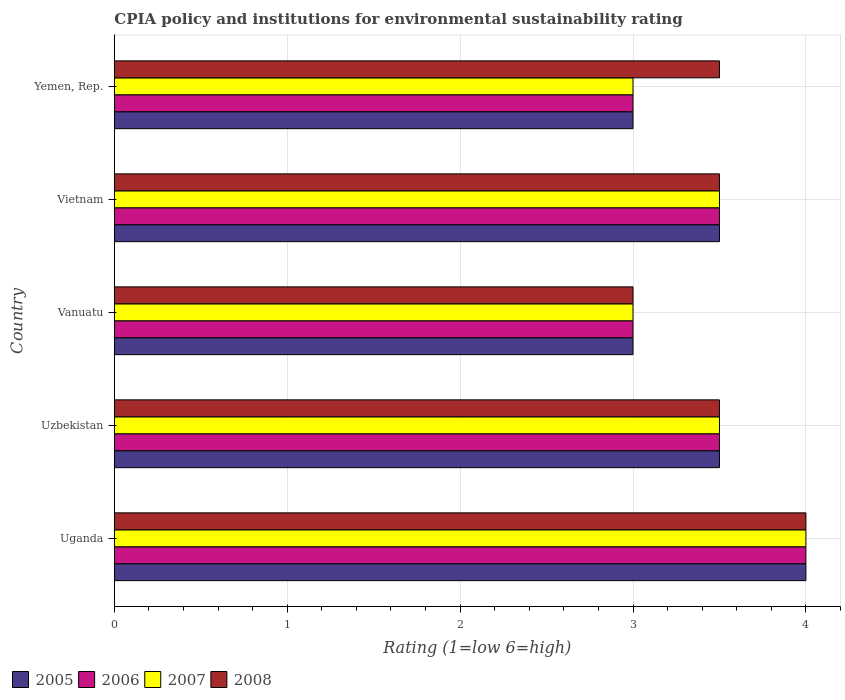How many bars are there on the 2nd tick from the bottom?
Your answer should be very brief. 4. What is the label of the 1st group of bars from the top?
Your response must be concise. Yemen, Rep. Across all countries, what is the maximum CPIA rating in 2007?
Provide a short and direct response. 4. In which country was the CPIA rating in 2007 maximum?
Your answer should be very brief. Uganda. In which country was the CPIA rating in 2007 minimum?
Provide a short and direct response. Vanuatu. What is the total CPIA rating in 2007 in the graph?
Provide a succinct answer. 17. What is the difference between the CPIA rating in 2005 in Uganda and that in Vanuatu?
Your response must be concise. 1. What is the difference between the CPIA rating in 2006 in Uzbekistan and the CPIA rating in 2007 in Yemen, Rep.?
Keep it short and to the point. 0.5. What is the difference between the CPIA rating in 2005 and CPIA rating in 2008 in Uganda?
Make the answer very short. 0. What is the ratio of the CPIA rating in 2005 in Uzbekistan to that in Yemen, Rep.?
Your response must be concise. 1.17. What is the difference between the highest and the second highest CPIA rating in 2005?
Provide a short and direct response. 0.5. Is the sum of the CPIA rating in 2007 in Uzbekistan and Vietnam greater than the maximum CPIA rating in 2005 across all countries?
Offer a very short reply. Yes. What does the 2nd bar from the top in Yemen, Rep. represents?
Your answer should be very brief. 2007. What does the 4th bar from the bottom in Uganda represents?
Ensure brevity in your answer.  2008. Is it the case that in every country, the sum of the CPIA rating in 2005 and CPIA rating in 2007 is greater than the CPIA rating in 2008?
Provide a succinct answer. Yes. How many bars are there?
Your answer should be very brief. 20. Are all the bars in the graph horizontal?
Make the answer very short. Yes. What is the difference between two consecutive major ticks on the X-axis?
Your response must be concise. 1. Where does the legend appear in the graph?
Your response must be concise. Bottom left. How are the legend labels stacked?
Your answer should be compact. Horizontal. What is the title of the graph?
Provide a short and direct response. CPIA policy and institutions for environmental sustainability rating. What is the label or title of the X-axis?
Offer a very short reply. Rating (1=low 6=high). What is the label or title of the Y-axis?
Offer a very short reply. Country. What is the Rating (1=low 6=high) of 2006 in Uganda?
Ensure brevity in your answer.  4. What is the Rating (1=low 6=high) in 2007 in Uganda?
Ensure brevity in your answer.  4. What is the Rating (1=low 6=high) of 2006 in Uzbekistan?
Make the answer very short. 3.5. What is the Rating (1=low 6=high) of 2008 in Uzbekistan?
Your answer should be compact. 3.5. What is the Rating (1=low 6=high) of 2006 in Vanuatu?
Provide a short and direct response. 3. What is the Rating (1=low 6=high) of 2007 in Vanuatu?
Keep it short and to the point. 3. What is the Rating (1=low 6=high) in 2008 in Vanuatu?
Provide a short and direct response. 3. What is the Rating (1=low 6=high) of 2005 in Vietnam?
Give a very brief answer. 3.5. What is the Rating (1=low 6=high) of 2006 in Vietnam?
Your answer should be compact. 3.5. What is the Rating (1=low 6=high) in 2007 in Vietnam?
Offer a terse response. 3.5. What is the Rating (1=low 6=high) in 2005 in Yemen, Rep.?
Ensure brevity in your answer.  3. What is the Rating (1=low 6=high) in 2007 in Yemen, Rep.?
Keep it short and to the point. 3. Across all countries, what is the maximum Rating (1=low 6=high) in 2005?
Your answer should be very brief. 4. Across all countries, what is the minimum Rating (1=low 6=high) of 2005?
Keep it short and to the point. 3. Across all countries, what is the minimum Rating (1=low 6=high) of 2007?
Your answer should be very brief. 3. What is the total Rating (1=low 6=high) of 2005 in the graph?
Give a very brief answer. 17. What is the total Rating (1=low 6=high) of 2006 in the graph?
Provide a short and direct response. 17. What is the total Rating (1=low 6=high) of 2008 in the graph?
Provide a succinct answer. 17.5. What is the difference between the Rating (1=low 6=high) in 2005 in Uganda and that in Vanuatu?
Provide a short and direct response. 1. What is the difference between the Rating (1=low 6=high) in 2007 in Uganda and that in Vietnam?
Your answer should be compact. 0.5. What is the difference between the Rating (1=low 6=high) of 2008 in Uganda and that in Vietnam?
Ensure brevity in your answer.  0.5. What is the difference between the Rating (1=low 6=high) in 2007 in Uganda and that in Yemen, Rep.?
Provide a short and direct response. 1. What is the difference between the Rating (1=low 6=high) in 2008 in Uganda and that in Yemen, Rep.?
Provide a succinct answer. 0.5. What is the difference between the Rating (1=low 6=high) of 2006 in Uzbekistan and that in Vanuatu?
Make the answer very short. 0.5. What is the difference between the Rating (1=low 6=high) in 2005 in Uzbekistan and that in Vietnam?
Offer a terse response. 0. What is the difference between the Rating (1=low 6=high) in 2006 in Uzbekistan and that in Vietnam?
Provide a short and direct response. 0. What is the difference between the Rating (1=low 6=high) in 2007 in Uzbekistan and that in Vietnam?
Your answer should be compact. 0. What is the difference between the Rating (1=low 6=high) in 2005 in Uzbekistan and that in Yemen, Rep.?
Your answer should be compact. 0.5. What is the difference between the Rating (1=low 6=high) of 2006 in Uzbekistan and that in Yemen, Rep.?
Give a very brief answer. 0.5. What is the difference between the Rating (1=low 6=high) in 2007 in Uzbekistan and that in Yemen, Rep.?
Make the answer very short. 0.5. What is the difference between the Rating (1=low 6=high) of 2006 in Vanuatu and that in Vietnam?
Your answer should be very brief. -0.5. What is the difference between the Rating (1=low 6=high) of 2007 in Vanuatu and that in Vietnam?
Your answer should be very brief. -0.5. What is the difference between the Rating (1=low 6=high) of 2005 in Vanuatu and that in Yemen, Rep.?
Provide a succinct answer. 0. What is the difference between the Rating (1=low 6=high) in 2006 in Vanuatu and that in Yemen, Rep.?
Your answer should be compact. 0. What is the difference between the Rating (1=low 6=high) of 2007 in Vanuatu and that in Yemen, Rep.?
Your answer should be very brief. 0. What is the difference between the Rating (1=low 6=high) of 2008 in Vanuatu and that in Yemen, Rep.?
Ensure brevity in your answer.  -0.5. What is the difference between the Rating (1=low 6=high) of 2005 in Vietnam and that in Yemen, Rep.?
Offer a terse response. 0.5. What is the difference between the Rating (1=low 6=high) of 2006 in Vietnam and that in Yemen, Rep.?
Keep it short and to the point. 0.5. What is the difference between the Rating (1=low 6=high) in 2008 in Vietnam and that in Yemen, Rep.?
Your answer should be compact. 0. What is the difference between the Rating (1=low 6=high) of 2005 in Uganda and the Rating (1=low 6=high) of 2006 in Uzbekistan?
Offer a terse response. 0.5. What is the difference between the Rating (1=low 6=high) in 2005 in Uganda and the Rating (1=low 6=high) in 2007 in Uzbekistan?
Make the answer very short. 0.5. What is the difference between the Rating (1=low 6=high) in 2007 in Uganda and the Rating (1=low 6=high) in 2008 in Uzbekistan?
Give a very brief answer. 0.5. What is the difference between the Rating (1=low 6=high) of 2005 in Uganda and the Rating (1=low 6=high) of 2007 in Vanuatu?
Provide a short and direct response. 1. What is the difference between the Rating (1=low 6=high) of 2006 in Uganda and the Rating (1=low 6=high) of 2008 in Vanuatu?
Make the answer very short. 1. What is the difference between the Rating (1=low 6=high) of 2007 in Uganda and the Rating (1=low 6=high) of 2008 in Vanuatu?
Offer a very short reply. 1. What is the difference between the Rating (1=low 6=high) in 2005 in Uganda and the Rating (1=low 6=high) in 2008 in Vietnam?
Provide a short and direct response. 0.5. What is the difference between the Rating (1=low 6=high) in 2006 in Uganda and the Rating (1=low 6=high) in 2007 in Vietnam?
Provide a short and direct response. 0.5. What is the difference between the Rating (1=low 6=high) of 2007 in Uganda and the Rating (1=low 6=high) of 2008 in Vietnam?
Ensure brevity in your answer.  0.5. What is the difference between the Rating (1=low 6=high) of 2005 in Uganda and the Rating (1=low 6=high) of 2006 in Yemen, Rep.?
Provide a succinct answer. 1. What is the difference between the Rating (1=low 6=high) in 2005 in Uganda and the Rating (1=low 6=high) in 2007 in Yemen, Rep.?
Ensure brevity in your answer.  1. What is the difference between the Rating (1=low 6=high) of 2005 in Uganda and the Rating (1=low 6=high) of 2008 in Yemen, Rep.?
Make the answer very short. 0.5. What is the difference between the Rating (1=low 6=high) of 2006 in Uganda and the Rating (1=low 6=high) of 2008 in Yemen, Rep.?
Offer a terse response. 0.5. What is the difference between the Rating (1=low 6=high) in 2005 in Uzbekistan and the Rating (1=low 6=high) in 2006 in Vanuatu?
Give a very brief answer. 0.5. What is the difference between the Rating (1=low 6=high) in 2005 in Uzbekistan and the Rating (1=low 6=high) in 2007 in Vanuatu?
Your response must be concise. 0.5. What is the difference between the Rating (1=low 6=high) in 2005 in Uzbekistan and the Rating (1=low 6=high) in 2008 in Vanuatu?
Provide a short and direct response. 0.5. What is the difference between the Rating (1=low 6=high) of 2005 in Uzbekistan and the Rating (1=low 6=high) of 2007 in Vietnam?
Provide a short and direct response. 0. What is the difference between the Rating (1=low 6=high) in 2006 in Uzbekistan and the Rating (1=low 6=high) in 2007 in Vietnam?
Provide a succinct answer. 0. What is the difference between the Rating (1=low 6=high) of 2006 in Uzbekistan and the Rating (1=low 6=high) of 2008 in Vietnam?
Offer a terse response. 0. What is the difference between the Rating (1=low 6=high) of 2007 in Uzbekistan and the Rating (1=low 6=high) of 2008 in Vietnam?
Ensure brevity in your answer.  0. What is the difference between the Rating (1=low 6=high) in 2006 in Uzbekistan and the Rating (1=low 6=high) in 2008 in Yemen, Rep.?
Provide a short and direct response. 0. What is the difference between the Rating (1=low 6=high) in 2007 in Uzbekistan and the Rating (1=low 6=high) in 2008 in Yemen, Rep.?
Keep it short and to the point. 0. What is the difference between the Rating (1=low 6=high) in 2005 in Vanuatu and the Rating (1=low 6=high) in 2007 in Vietnam?
Make the answer very short. -0.5. What is the difference between the Rating (1=low 6=high) of 2005 in Vanuatu and the Rating (1=low 6=high) of 2008 in Vietnam?
Provide a short and direct response. -0.5. What is the difference between the Rating (1=low 6=high) in 2006 in Vanuatu and the Rating (1=low 6=high) in 2007 in Vietnam?
Provide a succinct answer. -0.5. What is the difference between the Rating (1=low 6=high) of 2007 in Vanuatu and the Rating (1=low 6=high) of 2008 in Vietnam?
Your answer should be compact. -0.5. What is the difference between the Rating (1=low 6=high) of 2005 in Vanuatu and the Rating (1=low 6=high) of 2007 in Yemen, Rep.?
Ensure brevity in your answer.  0. What is the difference between the Rating (1=low 6=high) of 2005 in Vanuatu and the Rating (1=low 6=high) of 2008 in Yemen, Rep.?
Offer a very short reply. -0.5. What is the difference between the Rating (1=low 6=high) of 2006 in Vanuatu and the Rating (1=low 6=high) of 2007 in Yemen, Rep.?
Give a very brief answer. 0. What is the difference between the Rating (1=low 6=high) of 2006 in Vanuatu and the Rating (1=low 6=high) of 2008 in Yemen, Rep.?
Your answer should be very brief. -0.5. What is the difference between the Rating (1=low 6=high) of 2005 in Vietnam and the Rating (1=low 6=high) of 2006 in Yemen, Rep.?
Provide a short and direct response. 0.5. What is the difference between the Rating (1=low 6=high) in 2005 in Vietnam and the Rating (1=low 6=high) in 2008 in Yemen, Rep.?
Provide a succinct answer. 0. What is the difference between the Rating (1=low 6=high) in 2006 in Vietnam and the Rating (1=low 6=high) in 2007 in Yemen, Rep.?
Keep it short and to the point. 0.5. What is the difference between the Rating (1=low 6=high) of 2006 in Vietnam and the Rating (1=low 6=high) of 2008 in Yemen, Rep.?
Provide a short and direct response. 0. What is the difference between the Rating (1=low 6=high) in 2007 in Vietnam and the Rating (1=low 6=high) in 2008 in Yemen, Rep.?
Offer a very short reply. 0. What is the average Rating (1=low 6=high) of 2007 per country?
Keep it short and to the point. 3.4. What is the average Rating (1=low 6=high) of 2008 per country?
Provide a short and direct response. 3.5. What is the difference between the Rating (1=low 6=high) of 2005 and Rating (1=low 6=high) of 2008 in Uganda?
Your answer should be very brief. 0. What is the difference between the Rating (1=low 6=high) of 2006 and Rating (1=low 6=high) of 2008 in Uganda?
Keep it short and to the point. 0. What is the difference between the Rating (1=low 6=high) in 2005 and Rating (1=low 6=high) in 2006 in Uzbekistan?
Provide a short and direct response. 0. What is the difference between the Rating (1=low 6=high) of 2005 and Rating (1=low 6=high) of 2007 in Uzbekistan?
Provide a short and direct response. 0. What is the difference between the Rating (1=low 6=high) of 2005 and Rating (1=low 6=high) of 2008 in Uzbekistan?
Provide a succinct answer. 0. What is the difference between the Rating (1=low 6=high) of 2007 and Rating (1=low 6=high) of 2008 in Uzbekistan?
Give a very brief answer. 0. What is the difference between the Rating (1=low 6=high) in 2005 and Rating (1=low 6=high) in 2006 in Vanuatu?
Offer a very short reply. 0. What is the difference between the Rating (1=low 6=high) in 2005 and Rating (1=low 6=high) in 2007 in Vanuatu?
Provide a short and direct response. 0. What is the difference between the Rating (1=low 6=high) in 2005 and Rating (1=low 6=high) in 2008 in Vanuatu?
Ensure brevity in your answer.  0. What is the difference between the Rating (1=low 6=high) in 2006 and Rating (1=low 6=high) in 2007 in Vanuatu?
Keep it short and to the point. 0. What is the difference between the Rating (1=low 6=high) of 2006 and Rating (1=low 6=high) of 2008 in Vanuatu?
Your response must be concise. 0. What is the difference between the Rating (1=low 6=high) of 2007 and Rating (1=low 6=high) of 2008 in Vanuatu?
Your response must be concise. 0. What is the difference between the Rating (1=low 6=high) in 2005 and Rating (1=low 6=high) in 2006 in Vietnam?
Offer a very short reply. 0. What is the difference between the Rating (1=low 6=high) in 2006 and Rating (1=low 6=high) in 2007 in Vietnam?
Provide a succinct answer. 0. What is the difference between the Rating (1=low 6=high) in 2006 and Rating (1=low 6=high) in 2008 in Vietnam?
Ensure brevity in your answer.  0. What is the difference between the Rating (1=low 6=high) in 2007 and Rating (1=low 6=high) in 2008 in Vietnam?
Ensure brevity in your answer.  0. What is the difference between the Rating (1=low 6=high) in 2005 and Rating (1=low 6=high) in 2006 in Yemen, Rep.?
Offer a terse response. 0. What is the difference between the Rating (1=low 6=high) in 2006 and Rating (1=low 6=high) in 2007 in Yemen, Rep.?
Your response must be concise. 0. What is the difference between the Rating (1=low 6=high) of 2006 and Rating (1=low 6=high) of 2008 in Yemen, Rep.?
Your response must be concise. -0.5. What is the difference between the Rating (1=low 6=high) in 2007 and Rating (1=low 6=high) in 2008 in Yemen, Rep.?
Make the answer very short. -0.5. What is the ratio of the Rating (1=low 6=high) in 2005 in Uganda to that in Uzbekistan?
Provide a succinct answer. 1.14. What is the ratio of the Rating (1=low 6=high) in 2007 in Uganda to that in Uzbekistan?
Ensure brevity in your answer.  1.14. What is the ratio of the Rating (1=low 6=high) of 2007 in Uganda to that in Vanuatu?
Provide a short and direct response. 1.33. What is the ratio of the Rating (1=low 6=high) in 2005 in Uganda to that in Vietnam?
Ensure brevity in your answer.  1.14. What is the ratio of the Rating (1=low 6=high) in 2006 in Uganda to that in Vietnam?
Provide a succinct answer. 1.14. What is the ratio of the Rating (1=low 6=high) in 2007 in Uganda to that in Vietnam?
Ensure brevity in your answer.  1.14. What is the ratio of the Rating (1=low 6=high) of 2007 in Uganda to that in Yemen, Rep.?
Provide a short and direct response. 1.33. What is the ratio of the Rating (1=low 6=high) of 2005 in Uzbekistan to that in Vanuatu?
Provide a succinct answer. 1.17. What is the ratio of the Rating (1=low 6=high) in 2007 in Uzbekistan to that in Vietnam?
Make the answer very short. 1. What is the ratio of the Rating (1=low 6=high) of 2005 in Vanuatu to that in Vietnam?
Make the answer very short. 0.86. What is the ratio of the Rating (1=low 6=high) of 2008 in Vanuatu to that in Vietnam?
Provide a short and direct response. 0.86. What is the ratio of the Rating (1=low 6=high) in 2008 in Vanuatu to that in Yemen, Rep.?
Your answer should be very brief. 0.86. What is the ratio of the Rating (1=low 6=high) of 2005 in Vietnam to that in Yemen, Rep.?
Your response must be concise. 1.17. What is the ratio of the Rating (1=low 6=high) of 2007 in Vietnam to that in Yemen, Rep.?
Keep it short and to the point. 1.17. What is the ratio of the Rating (1=low 6=high) of 2008 in Vietnam to that in Yemen, Rep.?
Give a very brief answer. 1. What is the difference between the highest and the second highest Rating (1=low 6=high) in 2006?
Provide a succinct answer. 0.5. What is the difference between the highest and the lowest Rating (1=low 6=high) of 2005?
Make the answer very short. 1. What is the difference between the highest and the lowest Rating (1=low 6=high) of 2006?
Your answer should be compact. 1. What is the difference between the highest and the lowest Rating (1=low 6=high) of 2007?
Give a very brief answer. 1. 